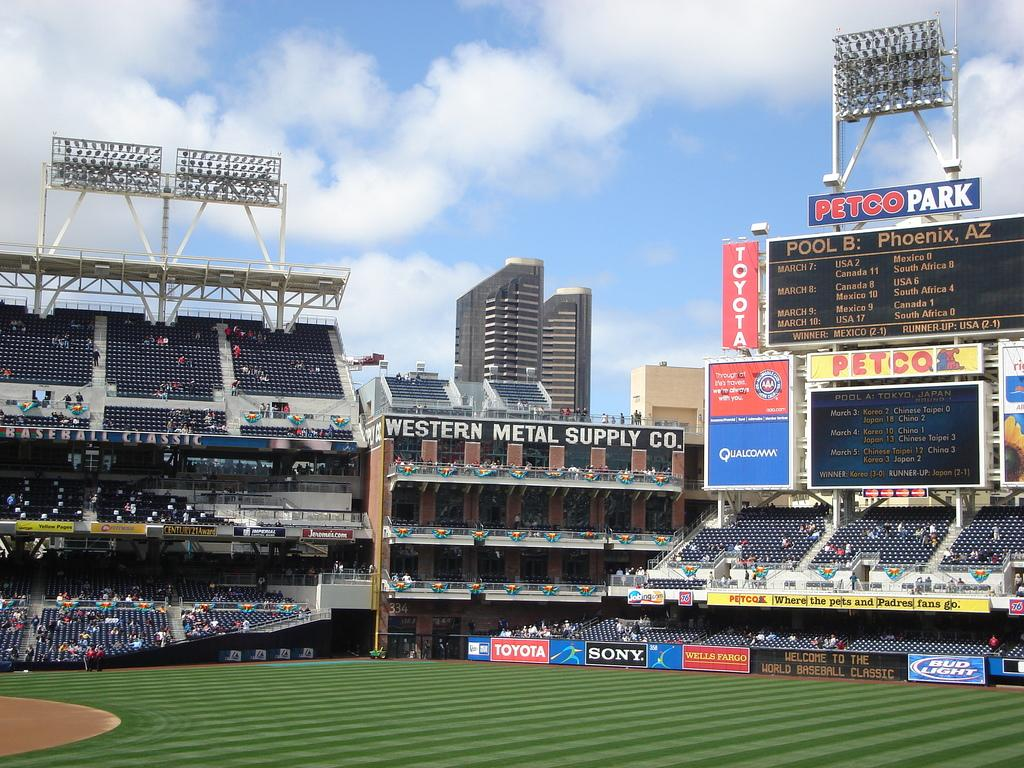Provide a one-sentence caption for the provided image. The Petco Park showing Pool B: Phoenix, AZ and Pool A: Tokyo, Japan. 